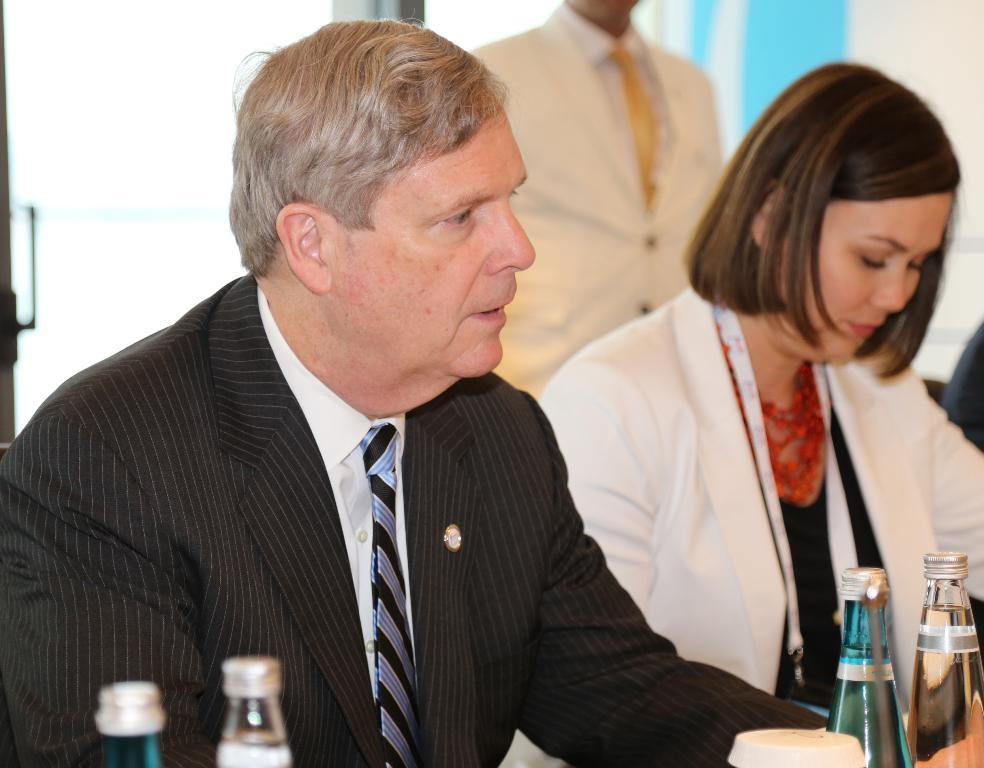How many people are seated in the image? There are two people seated on chairs in the image. What can be seen on the table in the image? There are water bottles on a table in the image. Can you describe the person in the background of the image? There is a man standing in the background of the image. What type of flowers are on the table next to the water bottles in the image? There are no flowers present on the table in the image; only water bottles are visible. How many passengers are seated in the image? The term "passenger" is not applicable in this context, as the people seated in the image are not on a vehicle or mode of transportation. 